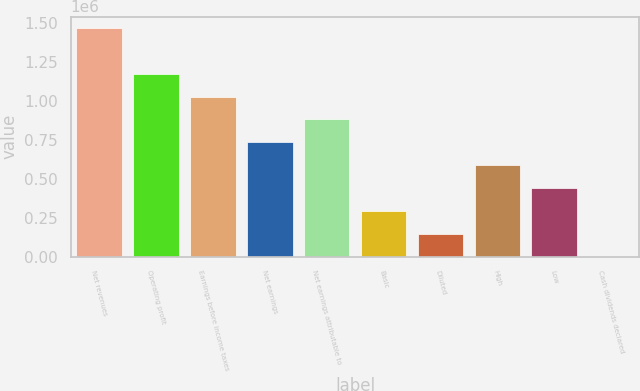<chart> <loc_0><loc_0><loc_500><loc_500><bar_chart><fcel>Net revenues<fcel>Operating profit<fcel>Earnings before income taxes<fcel>Net earnings<fcel>Net earnings attributable to<fcel>Basic<fcel>Diluted<fcel>High<fcel>Low<fcel>Cash dividends declared<nl><fcel>1.46535e+06<fcel>1.17228e+06<fcel>1.02575e+06<fcel>732677<fcel>879213<fcel>293071<fcel>146536<fcel>586142<fcel>439607<fcel>0.46<nl></chart> 